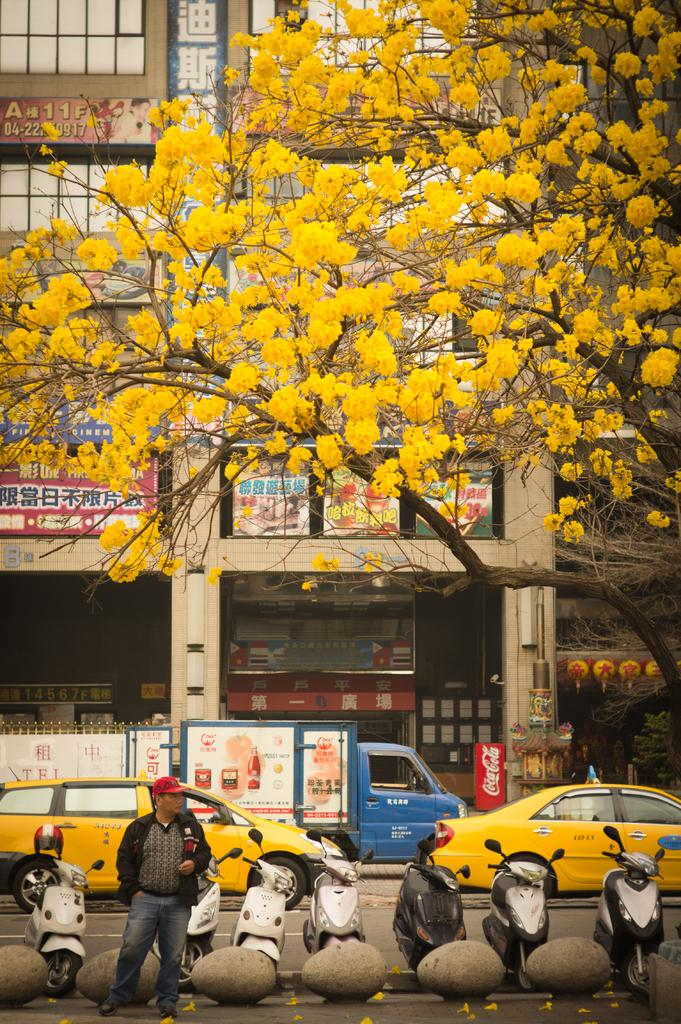<image>
Give a short and clear explanation of the subsequent image. A city scene with a Coca Cola machine in the middle of it. 